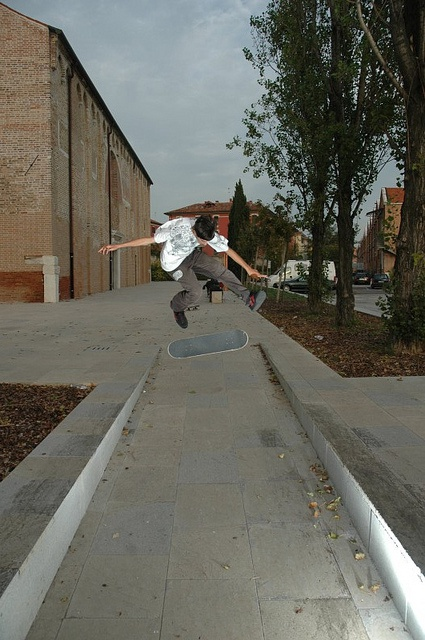Describe the objects in this image and their specific colors. I can see people in gray, lightgray, black, and darkgray tones, skateboard in gray and darkgray tones, truck in gray, darkgray, and black tones, car in gray and black tones, and car in gray, black, and purple tones in this image. 